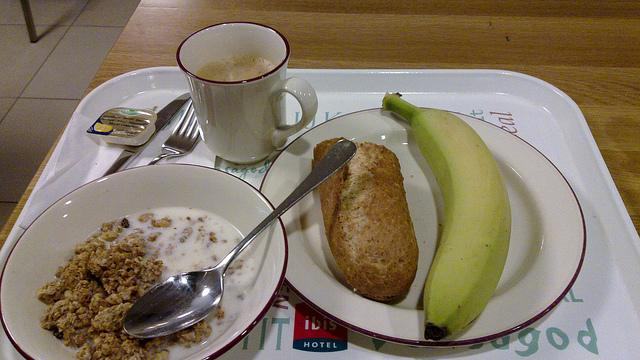What is on the plate all the way to the right? Please explain your reasoning. banana. It's a unripe one. 